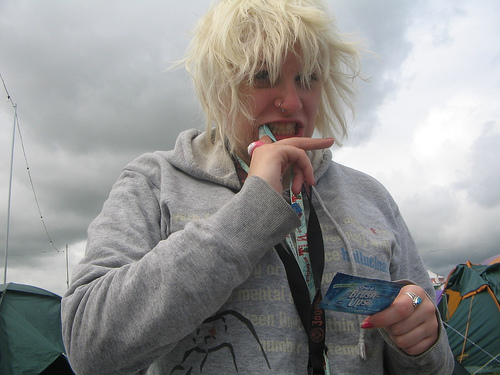Identify the text displayed in this image. Brush Ups ce or terms thin een mental 